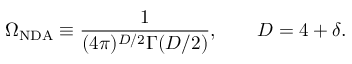<formula> <loc_0><loc_0><loc_500><loc_500>\Omega _ { N D A } \equiv \frac { 1 } { ( 4 \pi ) ^ { D / 2 } \Gamma ( D / 2 ) } , \quad D = 4 + \delta .</formula> 